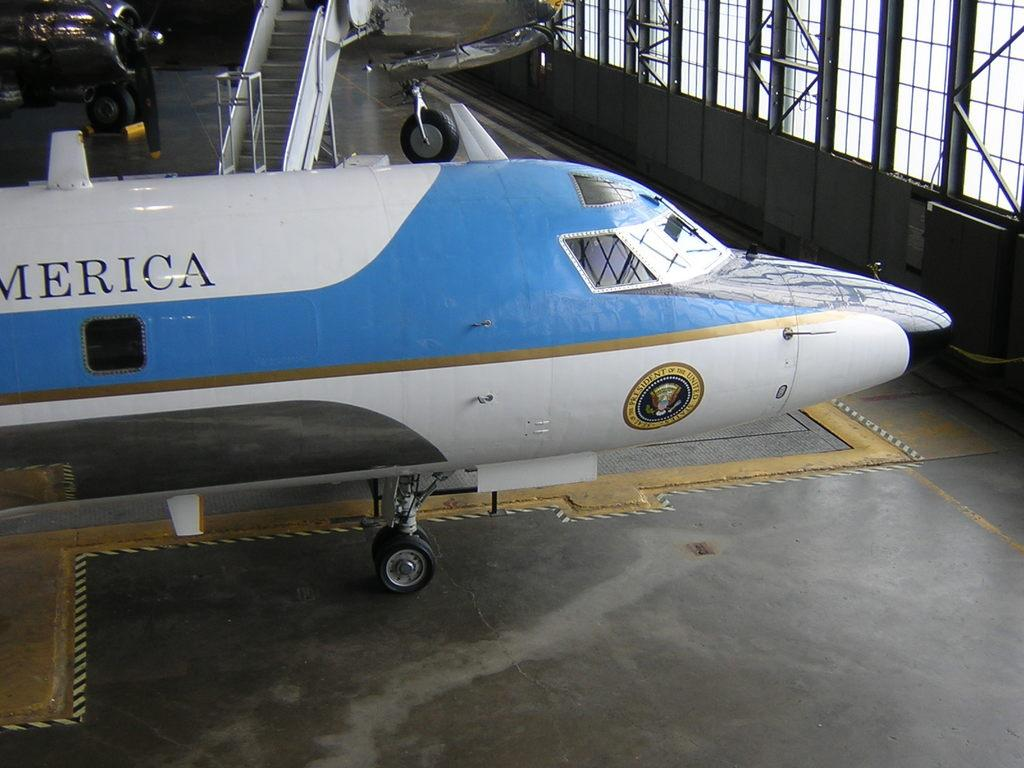<image>
Write a terse but informative summary of the picture. America blue and white plane with the president of the united states seal. 